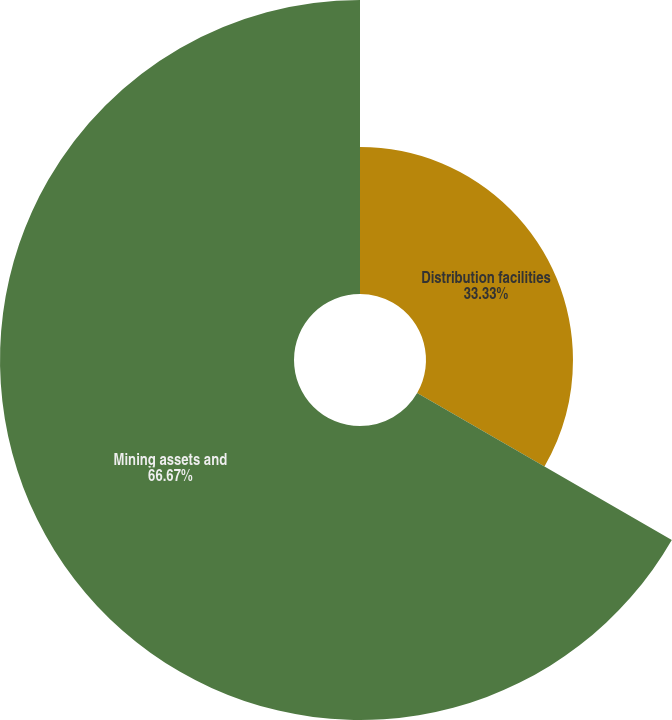Convert chart. <chart><loc_0><loc_0><loc_500><loc_500><pie_chart><fcel>Distribution facilities<fcel>Mining assets and<nl><fcel>33.33%<fcel>66.67%<nl></chart> 